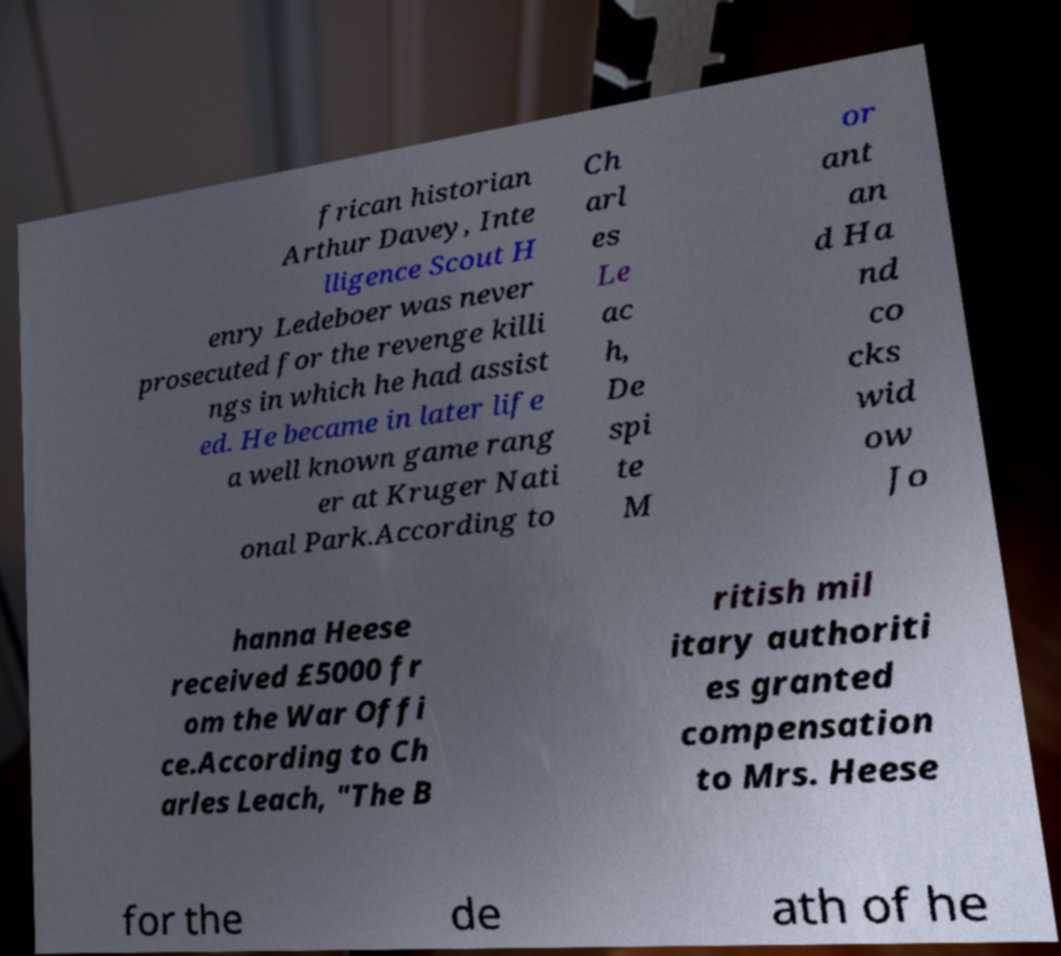There's text embedded in this image that I need extracted. Can you transcribe it verbatim? frican historian Arthur Davey, Inte lligence Scout H enry Ledeboer was never prosecuted for the revenge killi ngs in which he had assist ed. He became in later life a well known game rang er at Kruger Nati onal Park.According to Ch arl es Le ac h, De spi te M or ant an d Ha nd co cks wid ow Jo hanna Heese received £5000 fr om the War Offi ce.According to Ch arles Leach, "The B ritish mil itary authoriti es granted compensation to Mrs. Heese for the de ath of he 